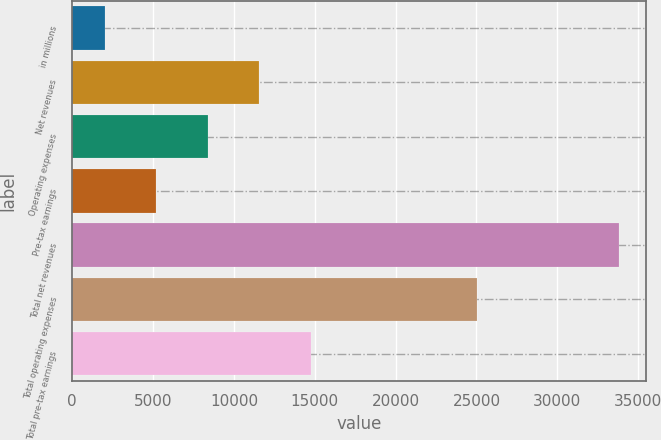Convert chart. <chart><loc_0><loc_0><loc_500><loc_500><bar_chart><fcel>in millions<fcel>Net revenues<fcel>Operating expenses<fcel>Pre-tax earnings<fcel>Total net revenues<fcel>Total operating expenses<fcel>Total pre-tax earnings<nl><fcel>2015<fcel>11556.5<fcel>8376<fcel>5195.5<fcel>33820<fcel>25042<fcel>14737<nl></chart> 